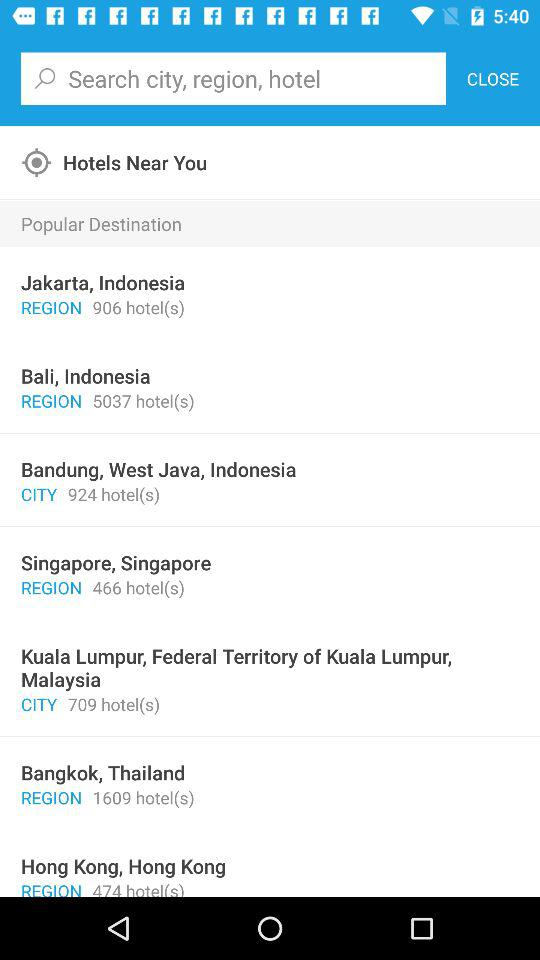How many hotels are there in Singapore, Singapore? There are 466 hotels. 